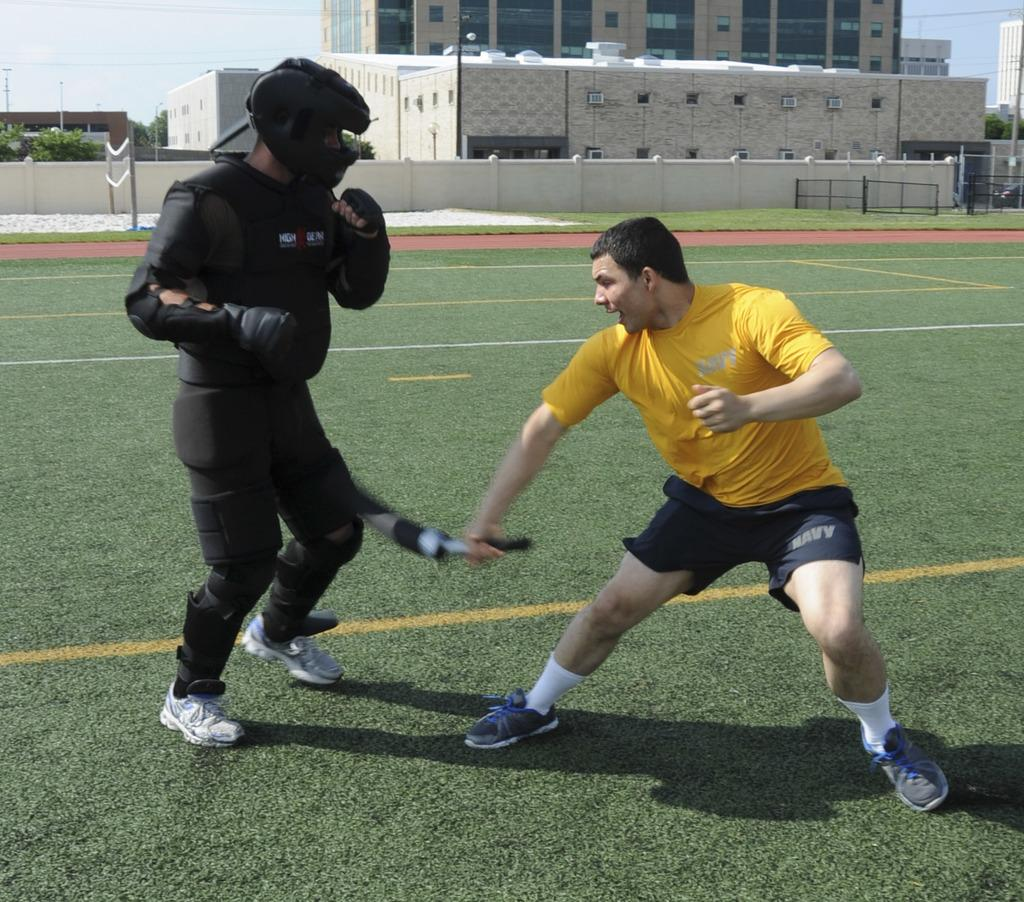<image>
Render a clear and concise summary of the photo. A boy is fencing with another man and is wearing shorts that say Navy 